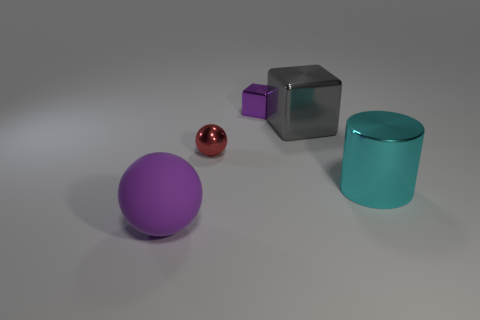Is there anything else that is the same material as the large purple sphere?
Provide a short and direct response. No. What size is the cube that is the same color as the large sphere?
Keep it short and to the point. Small. What shape is the rubber object that is the same color as the small block?
Your answer should be compact. Sphere. What is the color of the sphere in front of the small red shiny thing?
Your answer should be very brief. Purple. Is the number of cyan cylinders that are behind the purple matte object greater than the number of big blocks?
Provide a succinct answer. No. What color is the small cube?
Keep it short and to the point. Purple. What is the shape of the small shiny object in front of the purple thing behind the object that is left of the shiny ball?
Offer a very short reply. Sphere. There is a thing that is both behind the metal ball and in front of the small purple cube; what is its material?
Your answer should be compact. Metal. There is a purple object to the right of the purple rubber ball on the left side of the large cyan thing; what shape is it?
Offer a terse response. Cube. Is there anything else of the same color as the large rubber object?
Provide a succinct answer. Yes. 